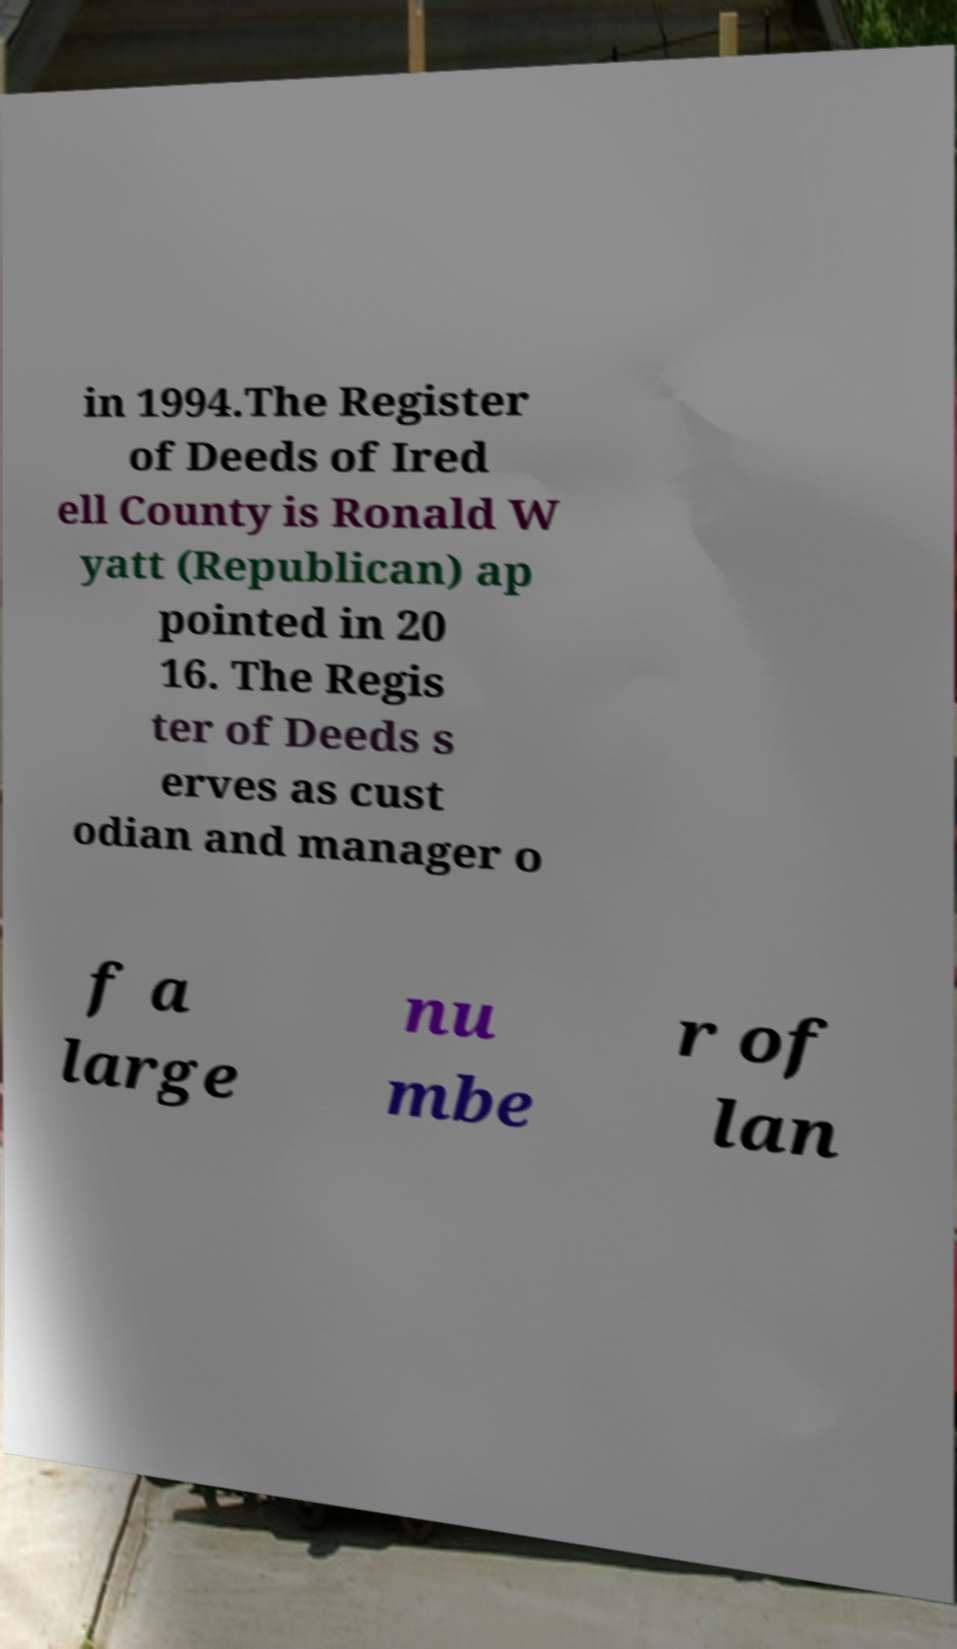Please read and relay the text visible in this image. What does it say? in 1994.The Register of Deeds of Ired ell County is Ronald W yatt (Republican) ap pointed in 20 16. The Regis ter of Deeds s erves as cust odian and manager o f a large nu mbe r of lan 